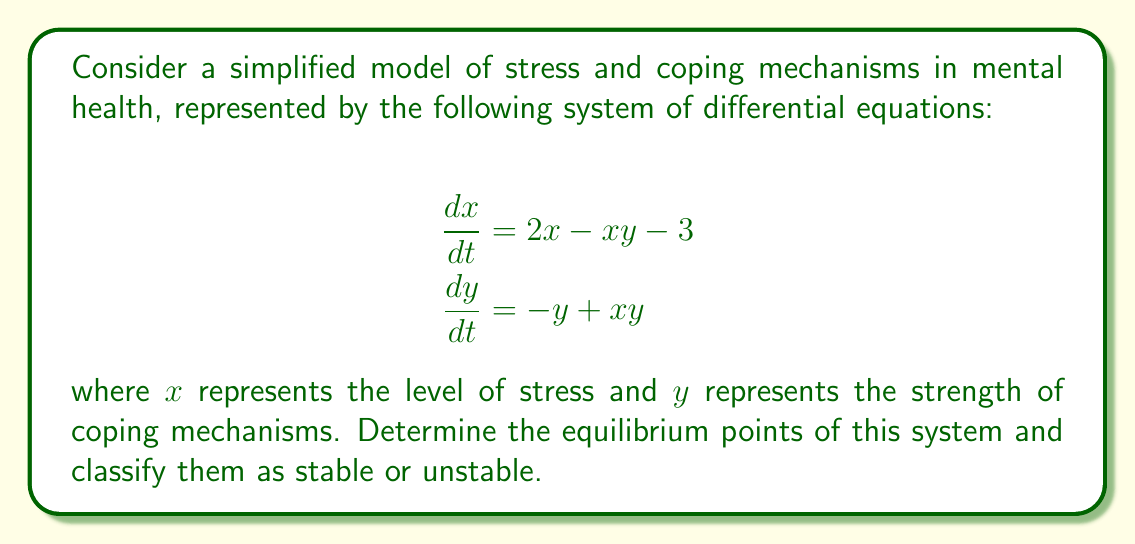Help me with this question. To find the equilibrium points, we set both equations equal to zero and solve for x and y:

1) Set equations to zero:
   $$\begin{align}
   2x - xy - 3 &= 0 \\
   -y + xy &= 0
   \end{align}$$

2) From the second equation:
   $xy = y$
   $y(x - 1) = 0$
   So, either $y = 0$ or $x = 1$

3) Case 1: If $y = 0$, substitute into first equation:
   $2x - 3 = 0$
   $x = \frac{3}{2}$
   Equilibrium point: $(\frac{3}{2}, 0)$

4) Case 2: If $x = 1$, substitute into first equation:
   $2(1) - y - 3 = 0$
   $y = -1$
   Equilibrium point: $(1, -1)$

5) To classify stability, we compute the Jacobian matrix:
   $$J = \begin{bmatrix}
   2 - y & -x \\
   y & x - 1
   \end{bmatrix}$$

6) For $(\frac{3}{2}, 0)$:
   $$J_{(\frac{3}{2}, 0)} = \begin{bmatrix}
   2 & -\frac{3}{2} \\
   0 & \frac{1}{2}
   \end{bmatrix}$$
   Eigenvalues: $\lambda_1 = 2$, $\lambda_2 = \frac{1}{2}$
   Both positive, so this point is unstable.

7) For $(1, -1)$:
   $$J_{(1, -1)} = \begin{bmatrix}
   3 & -1 \\
   -1 & 0
   \end{bmatrix}$$
   Eigenvalues: $\lambda_{1,2} = \frac{3 \pm \sqrt{13}}{2}$
   Both positive, so this point is also unstable.
Answer: Equilibrium points: $(\frac{3}{2}, 0)$ and $(1, -1)$, both unstable. 